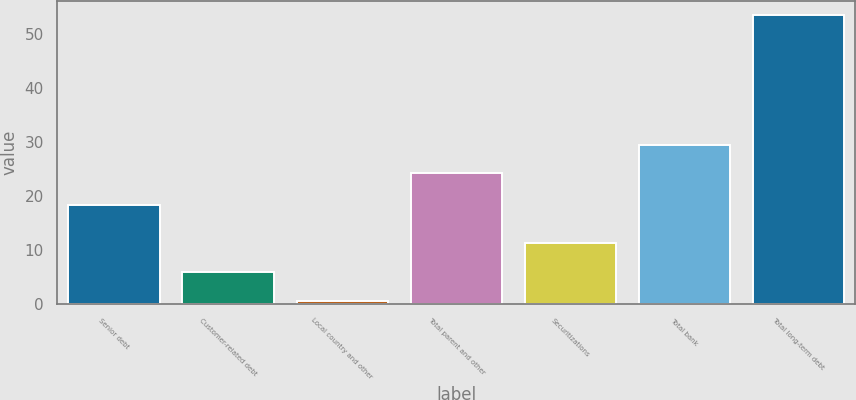Convert chart to OTSL. <chart><loc_0><loc_0><loc_500><loc_500><bar_chart><fcel>Senior debt<fcel>Customer-related debt<fcel>Local country and other<fcel>Total parent and other<fcel>Securitizations<fcel>Total bank<fcel>Total long-term debt<nl><fcel>18.4<fcel>5.89<fcel>0.6<fcel>24.2<fcel>11.18<fcel>29.49<fcel>53.5<nl></chart> 